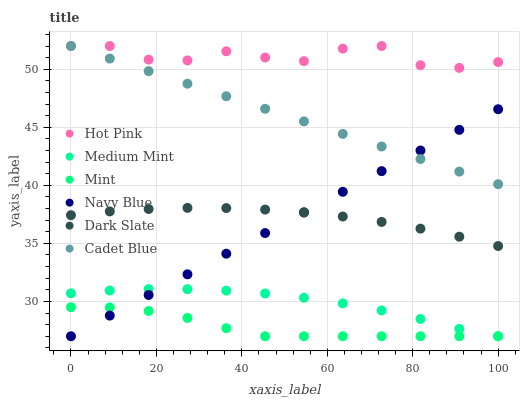Does Mint have the minimum area under the curve?
Answer yes or no. Yes. Does Hot Pink have the maximum area under the curve?
Answer yes or no. Yes. Does Cadet Blue have the minimum area under the curve?
Answer yes or no. No. Does Cadet Blue have the maximum area under the curve?
Answer yes or no. No. Is Cadet Blue the smoothest?
Answer yes or no. Yes. Is Hot Pink the roughest?
Answer yes or no. Yes. Is Navy Blue the smoothest?
Answer yes or no. No. Is Navy Blue the roughest?
Answer yes or no. No. Does Medium Mint have the lowest value?
Answer yes or no. Yes. Does Cadet Blue have the lowest value?
Answer yes or no. No. Does Hot Pink have the highest value?
Answer yes or no. Yes. Does Navy Blue have the highest value?
Answer yes or no. No. Is Navy Blue less than Hot Pink?
Answer yes or no. Yes. Is Cadet Blue greater than Mint?
Answer yes or no. Yes. Does Navy Blue intersect Cadet Blue?
Answer yes or no. Yes. Is Navy Blue less than Cadet Blue?
Answer yes or no. No. Is Navy Blue greater than Cadet Blue?
Answer yes or no. No. Does Navy Blue intersect Hot Pink?
Answer yes or no. No. 